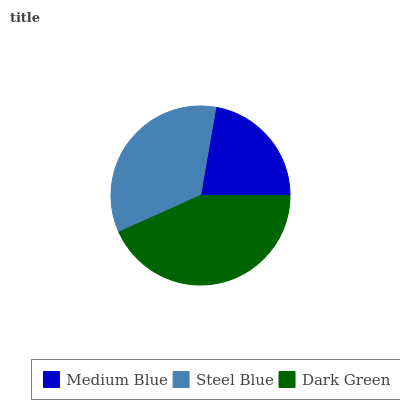Is Medium Blue the minimum?
Answer yes or no. Yes. Is Dark Green the maximum?
Answer yes or no. Yes. Is Steel Blue the minimum?
Answer yes or no. No. Is Steel Blue the maximum?
Answer yes or no. No. Is Steel Blue greater than Medium Blue?
Answer yes or no. Yes. Is Medium Blue less than Steel Blue?
Answer yes or no. Yes. Is Medium Blue greater than Steel Blue?
Answer yes or no. No. Is Steel Blue less than Medium Blue?
Answer yes or no. No. Is Steel Blue the high median?
Answer yes or no. Yes. Is Steel Blue the low median?
Answer yes or no. Yes. Is Dark Green the high median?
Answer yes or no. No. Is Medium Blue the low median?
Answer yes or no. No. 